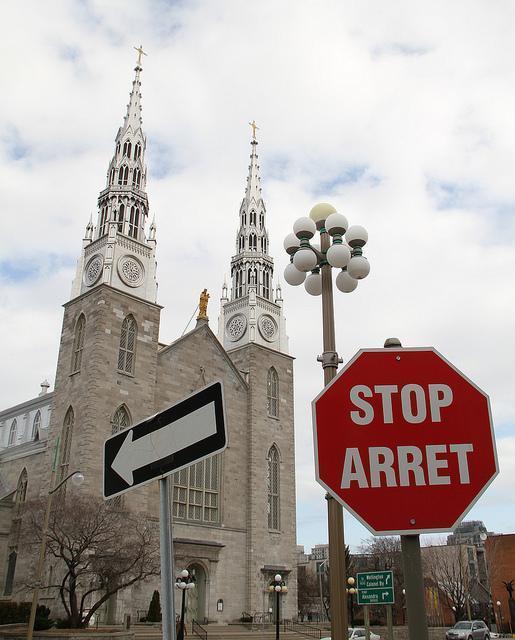How many words are on the sign?
Give a very brief answer. 2. How many stop signs are in the photo?
Give a very brief answer. 1. 